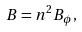Convert formula to latex. <formula><loc_0><loc_0><loc_500><loc_500>B = n ^ { 2 } B _ { \phi } ,</formula> 